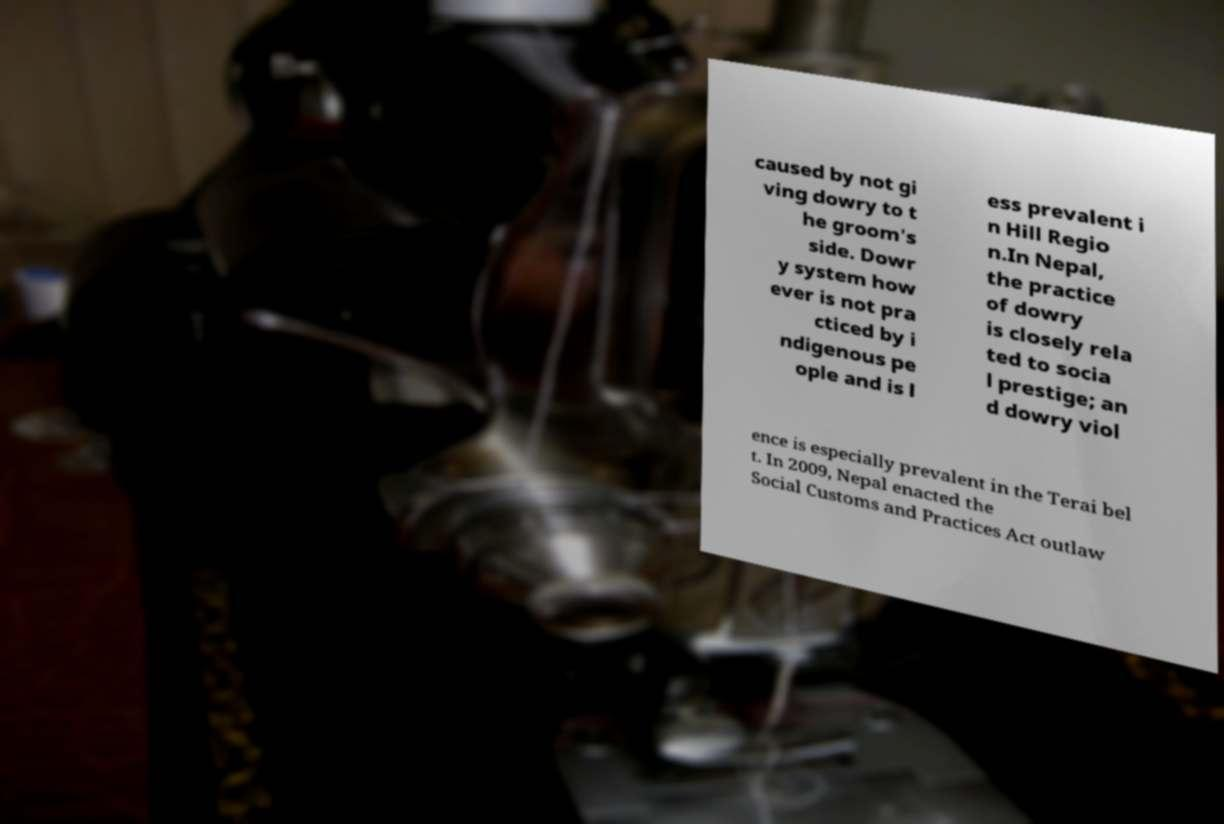Could you extract and type out the text from this image? caused by not gi ving dowry to t he groom's side. Dowr y system how ever is not pra cticed by i ndigenous pe ople and is l ess prevalent i n Hill Regio n.In Nepal, the practice of dowry is closely rela ted to socia l prestige; an d dowry viol ence is especially prevalent in the Terai bel t. In 2009, Nepal enacted the Social Customs and Practices Act outlaw 